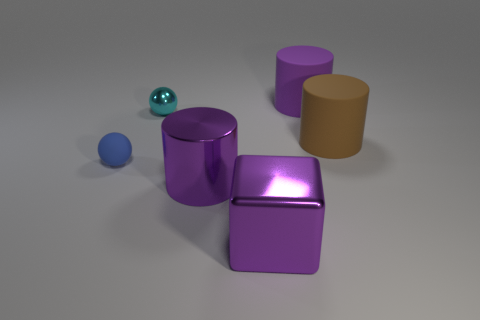What is the shape of the cyan thing behind the tiny blue object?
Your response must be concise. Sphere. The purple thing that is the same material as the small blue thing is what shape?
Offer a terse response. Cylinder. What number of rubber things are either purple cubes or big objects?
Make the answer very short. 2. What number of matte objects are left of the big purple cylinder that is in front of the big cylinder that is behind the shiny sphere?
Your answer should be very brief. 1. Does the cylinder in front of the brown rubber cylinder have the same size as the purple thing on the right side of the big purple cube?
Your answer should be compact. Yes. What material is the cyan thing that is the same shape as the blue thing?
Your response must be concise. Metal. How many tiny things are either brown cubes or brown things?
Make the answer very short. 0. What is the material of the purple cube?
Your answer should be very brief. Metal. There is a thing that is both on the left side of the shiny cylinder and on the right side of the small blue ball; what material is it made of?
Offer a terse response. Metal. There is a tiny shiny ball; is its color the same as the big matte object left of the brown matte thing?
Provide a succinct answer. No. 